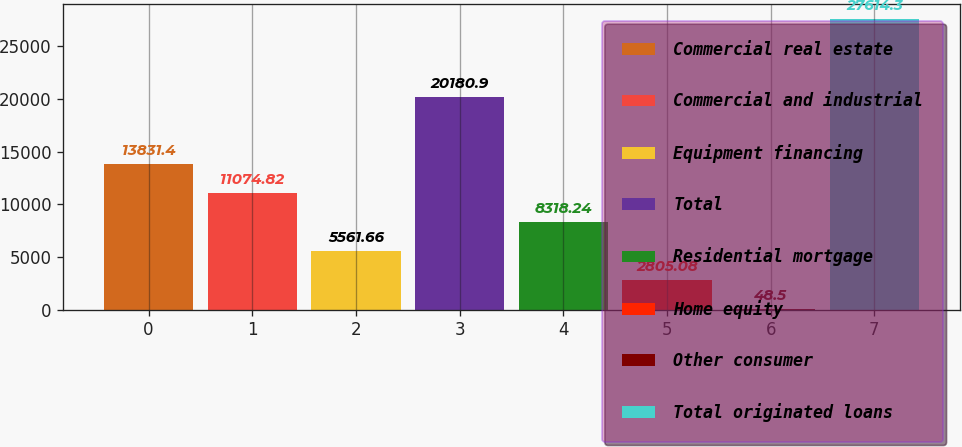Convert chart. <chart><loc_0><loc_0><loc_500><loc_500><bar_chart><fcel>Commercial real estate<fcel>Commercial and industrial<fcel>Equipment financing<fcel>Total<fcel>Residential mortgage<fcel>Home equity<fcel>Other consumer<fcel>Total originated loans<nl><fcel>13831.4<fcel>11074.8<fcel>5561.66<fcel>20180.9<fcel>8318.24<fcel>2805.08<fcel>48.5<fcel>27614.3<nl></chart> 